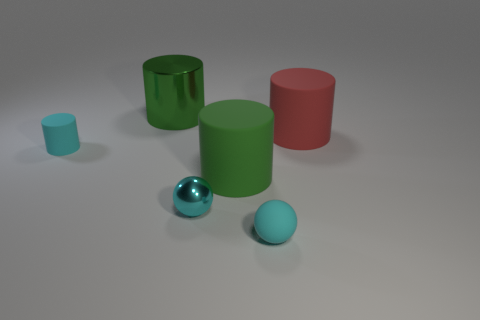Do the shiny thing that is behind the large red rubber cylinder and the large object that is in front of the big red matte cylinder have the same shape?
Give a very brief answer. Yes. What number of small things are cyan metallic balls or red rubber objects?
Your response must be concise. 1. The large green object that is made of the same material as the red thing is what shape?
Give a very brief answer. Cylinder. Does the large green metallic thing have the same shape as the red rubber object?
Provide a succinct answer. Yes. What color is the tiny cylinder?
Keep it short and to the point. Cyan. What number of objects are large green metallic things or cyan rubber cylinders?
Provide a short and direct response. 2. Is the number of green metallic cylinders that are to the right of the matte sphere less than the number of big red rubber spheres?
Keep it short and to the point. No. Are there more red objects that are on the left side of the green matte thing than red cylinders behind the big green metal cylinder?
Your answer should be very brief. No. There is a green cylinder in front of the tiny cyan cylinder; what is its material?
Provide a succinct answer. Rubber. Do the rubber ball and the cyan shiny object have the same size?
Ensure brevity in your answer.  Yes. 